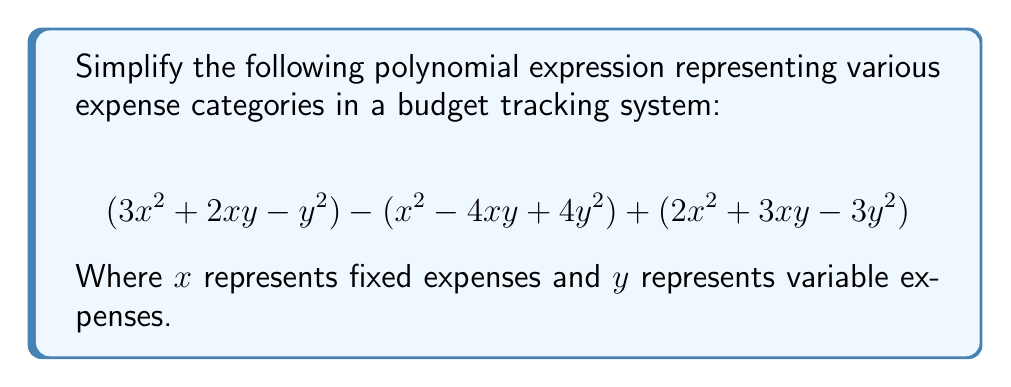Show me your answer to this math problem. Let's approach this step-by-step:

1) First, we'll group like terms:

   $$(3x^2 + 2xy - y^2) - (x^2 - 4xy + 4y^2) + (2x^2 + 3xy - 3y^2)$$

2) Distribute the negative sign to the second parenthesis:

   $$(3x^2 + 2xy - y^2) + (-x^2 + 4xy - 4y^2) + (2x^2 + 3xy - 3y^2)$$

3) Now, let's combine like terms:

   For $x^2$ terms: $3x^2 + (-x^2) + 2x^2 = 4x^2$
   
   For $xy$ terms: $2xy + 4xy + 3xy = 9xy$
   
   For $y^2$ terms: $-y^2 + (-4y^2) + (-3y^2) = -8y^2$

4) Writing our simplified expression:

   $$4x^2 + 9xy - 8y^2$$

This simplified form allows for easier tracking and comparison of fixed ($x^2$), mixed ($xy$), and variable ($y^2$) expense categories in the budget.
Answer: $$4x^2 + 9xy - 8y^2$$ 